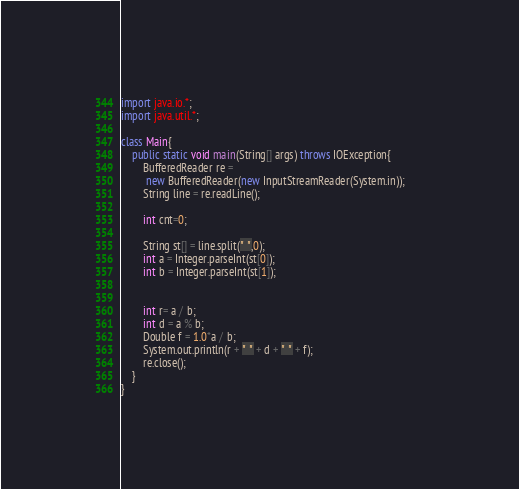Convert code to text. <code><loc_0><loc_0><loc_500><loc_500><_Java_>import java.io.*;
import java.util.*;
 
class Main{
    public static void main(String[] args) throws IOException{
        BufferedReader re =
         new BufferedReader(new InputStreamReader(System.in));       
        String line = re.readLine();       
         
        int cnt=0;
 
        String st[] = line.split(" ",0);
        int a = Integer.parseInt(st[0]);
        int b = Integer.parseInt(st[1]);
       
        
        int r= a / b;
        int d = a % b;
        Double f = 1.0*a / b;
        System.out.println(r + " " + d + " " + f); 
        re.close();
    }
}</code> 